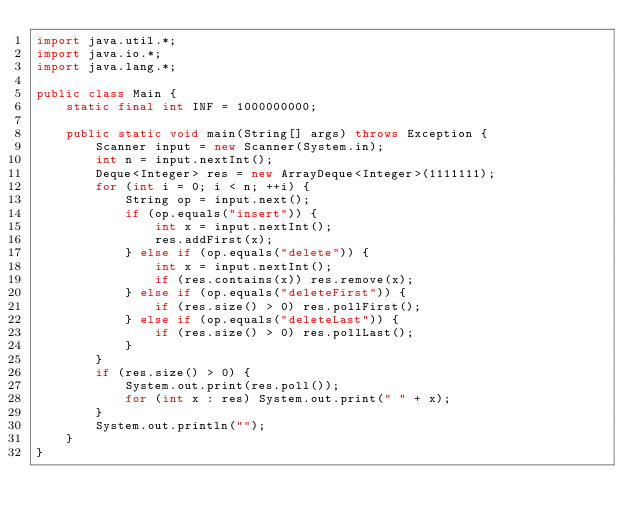Convert code to text. <code><loc_0><loc_0><loc_500><loc_500><_Java_>import java.util.*;
import java.io.*;
import java.lang.*;

public class Main {
    static final int INF = 1000000000;     
    
    public static void main(String[] args) throws Exception {                
        Scanner input = new Scanner(System.in);
        int n = input.nextInt();
        Deque<Integer> res = new ArrayDeque<Integer>(1111111);       
        for (int i = 0; i < n; ++i) {
            String op = input.next();
            if (op.equals("insert")) {
                int x = input.nextInt();
                res.addFirst(x);
            } else if (op.equals("delete")) {
                int x = input.nextInt();
                if (res.contains(x)) res.remove(x);
            } else if (op.equals("deleteFirst")) {
                if (res.size() > 0) res.pollFirst();                
            } else if (op.equals("deleteLast")) {
                if (res.size() > 0) res.pollLast();
            }
        }
        if (res.size() > 0) {
            System.out.print(res.poll());
            for (int x : res) System.out.print(" " + x);
        }        
        System.out.println("");
    }                
}</code> 